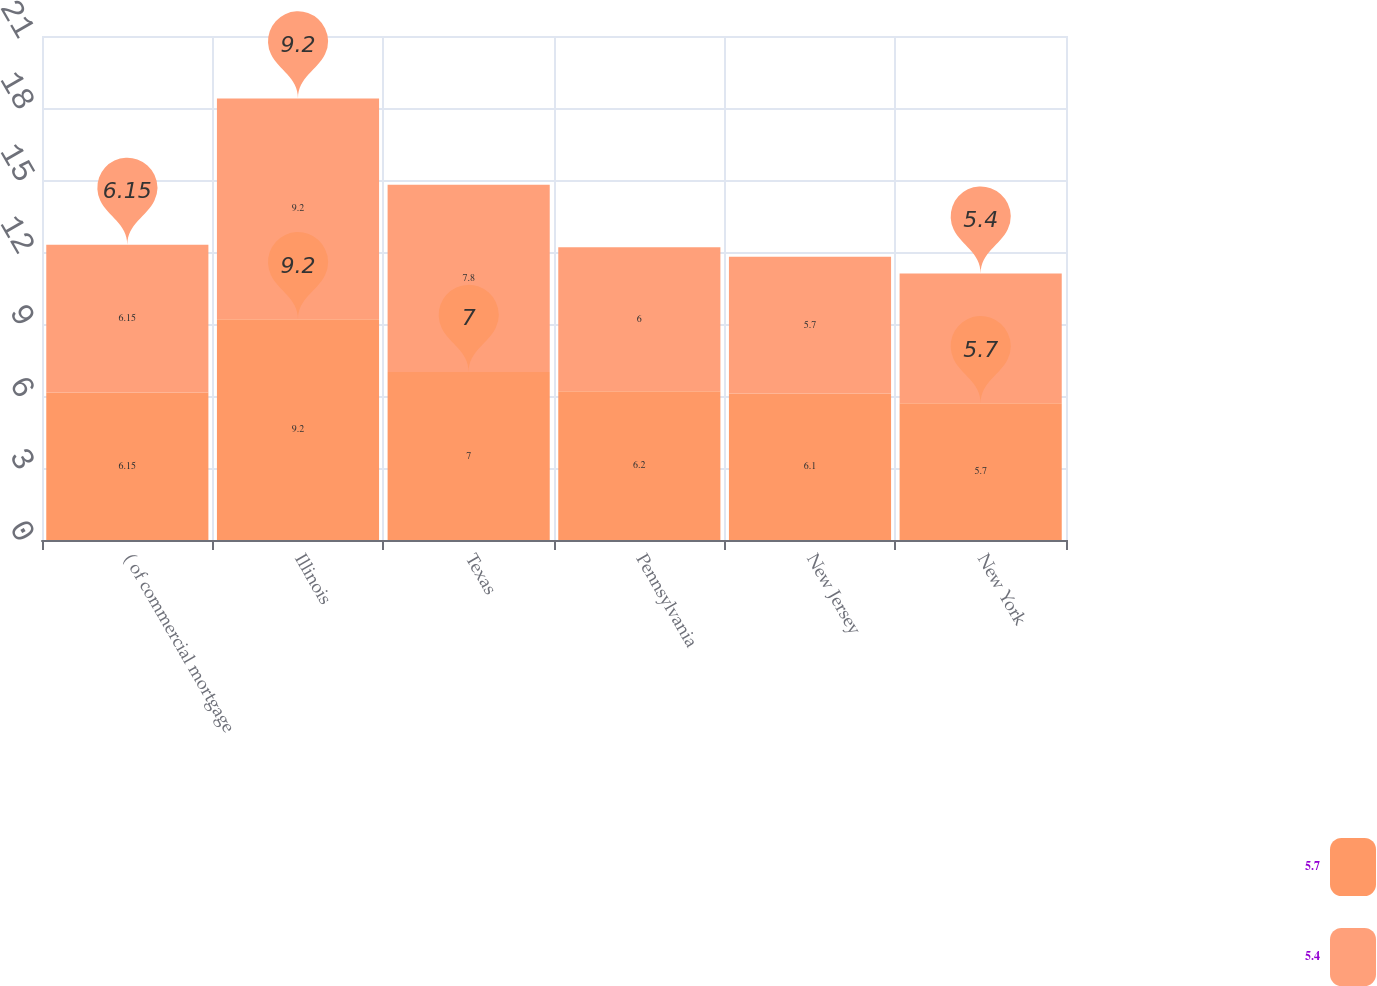Convert chart. <chart><loc_0><loc_0><loc_500><loc_500><stacked_bar_chart><ecel><fcel>( of commercial mortgage<fcel>Illinois<fcel>Texas<fcel>Pennsylvania<fcel>New Jersey<fcel>New York<nl><fcel>5.7<fcel>6.15<fcel>9.2<fcel>7<fcel>6.2<fcel>6.1<fcel>5.7<nl><fcel>5.4<fcel>6.15<fcel>9.2<fcel>7.8<fcel>6<fcel>5.7<fcel>5.4<nl></chart> 